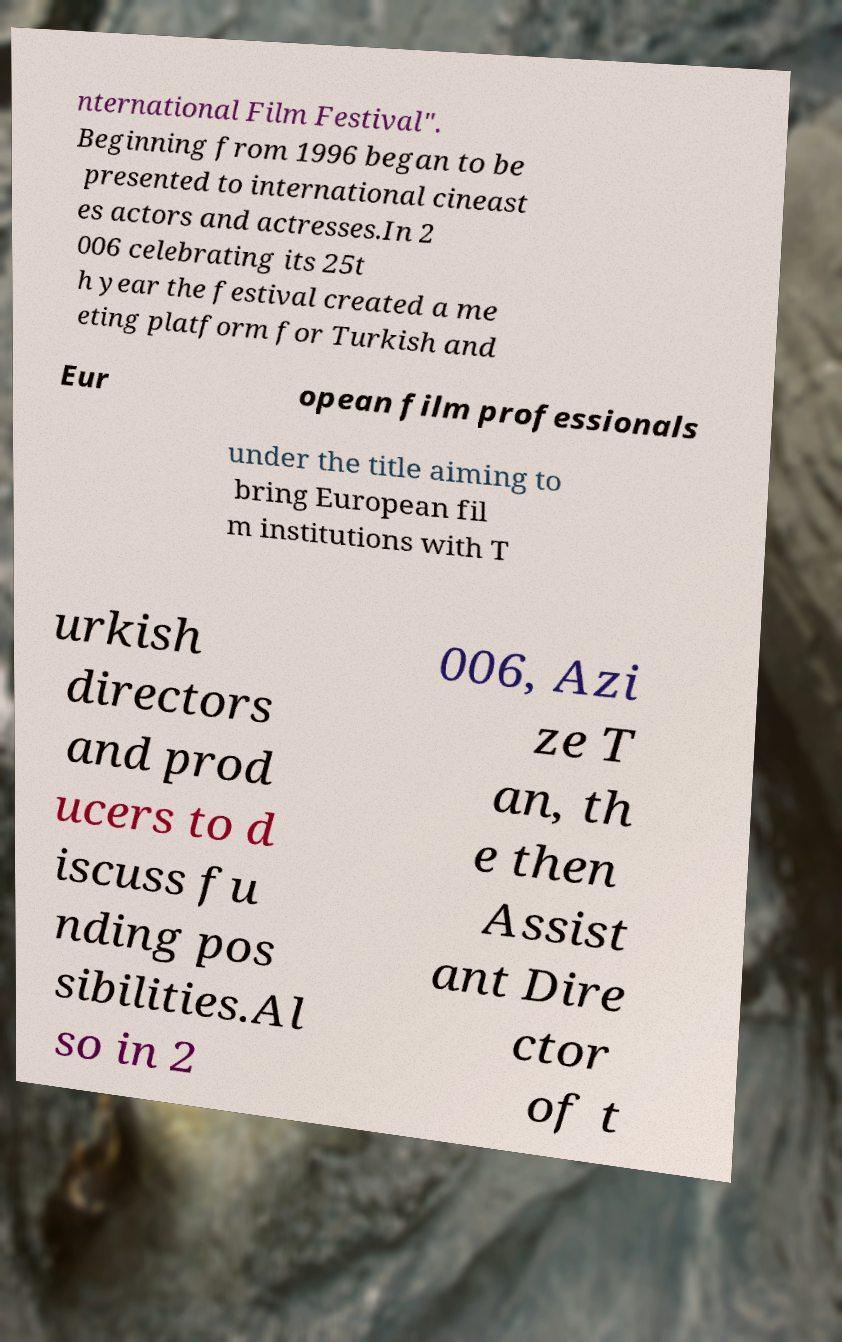I need the written content from this picture converted into text. Can you do that? nternational Film Festival". Beginning from 1996 began to be presented to international cineast es actors and actresses.In 2 006 celebrating its 25t h year the festival created a me eting platform for Turkish and Eur opean film professionals under the title aiming to bring European fil m institutions with T urkish directors and prod ucers to d iscuss fu nding pos sibilities.Al so in 2 006, Azi ze T an, th e then Assist ant Dire ctor of t 